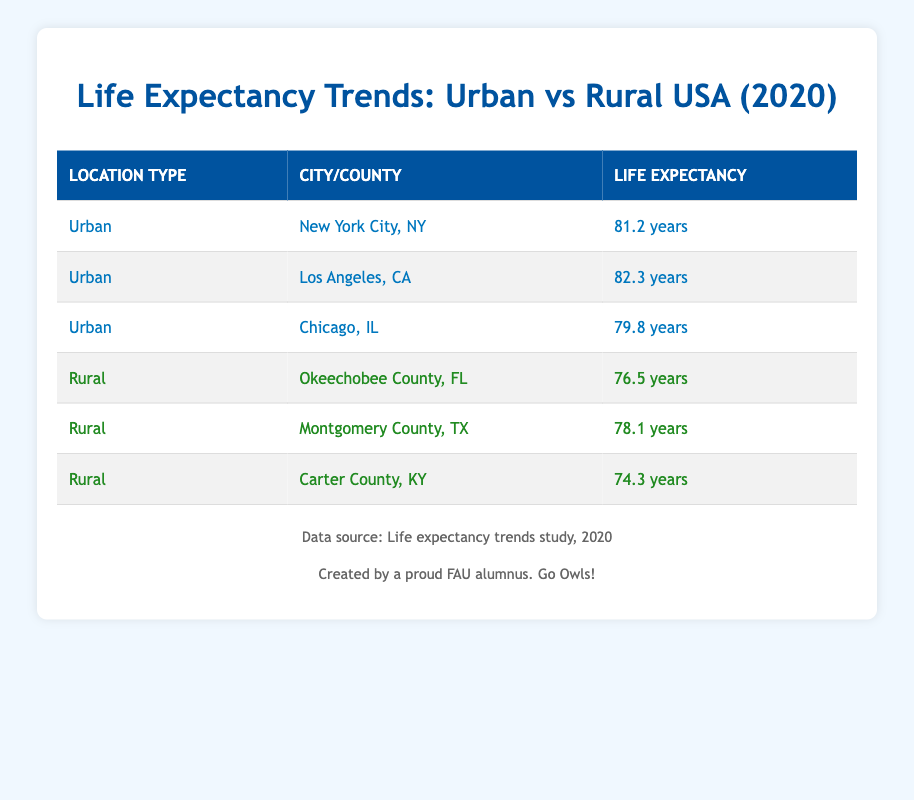What is the life expectancy in New York City? The table lists New York City under the urban location type, with a life expectancy of 81.2 years.
Answer: 81.2 years Which rural county has the lowest life expectancy? The life expectancy for Carter County, KY is 74.3 years, which is lower than that of Okeechobee County, FL (76.5 years) and Montgomery County, TX (78.1 years).
Answer: Carter County, KY What is the average life expectancy for urban areas listed in the table? The life expectancies for urban areas are 81.2, 82.3, and 79.8 years. Adding these gives 243.3 years, and dividing by 3 (the number of urban areas) results in an average of 81.1 years.
Answer: 81.1 years Is the life expectancy in rural areas generally lower than that of urban areas listed? Yes, the highest life expectancy for urban areas is 82.3 years (Los Angeles, CA), while the highest for rural is 78.1 years (Montgomery County, TX), confirming urban areas have generally higher life expectancies.
Answer: Yes What is the difference in life expectancy between the highest urban and rural areas? The highest urban life expectancy is 82.3 years (Los Angeles, CA) and the highest rural life expectancy is 78.1 years (Montgomery County, TX). The difference is 82.3 - 78.1 = 4.2 years.
Answer: 4.2 years What is the total life expectancy for all locations in the table? The life expectancies are 81.2, 82.3, 79.8, 76.5, 78.1, and 74.3 years. Summing these up gives 82.3 + 81.2 + 79.8 + 76.5 + 78.1 + 74.3 = 472.2 years.
Answer: 472.2 years Did any urban location have a life expectancy below 80 years? Yes, Chicago, IL has a life expectancy of 79.8 years, which is below 80.
Answer: Yes Which urban city has the second highest life expectancy? The urban cities listed are New York City, Los Angeles, and Chicago. Los Angeles has the highest (82.3 years), followed by New York City at 81.2 years, making it the second highest.
Answer: New York City, NY 